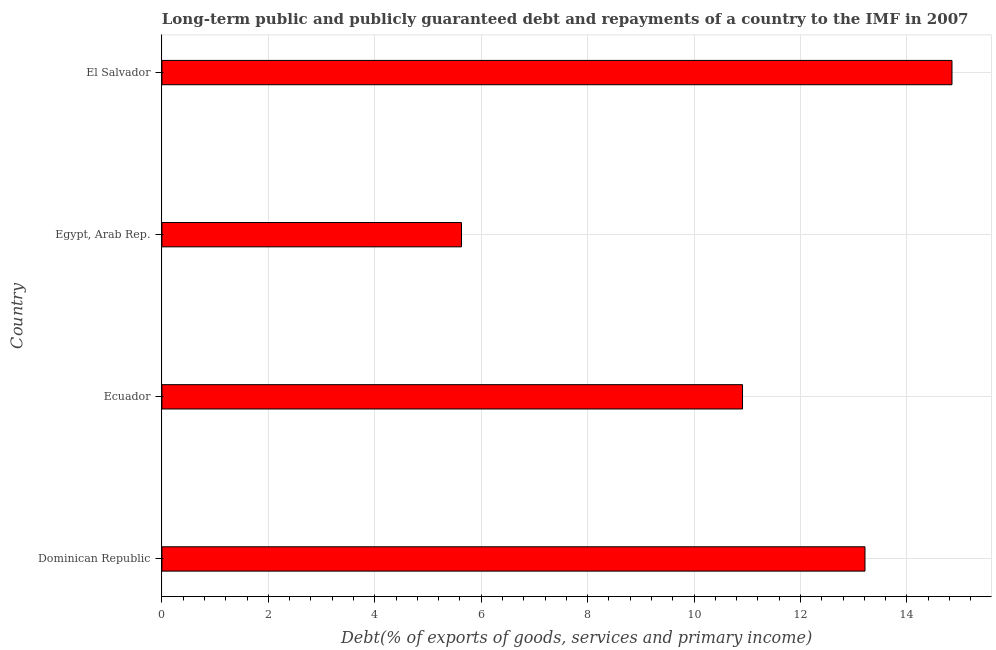Does the graph contain any zero values?
Offer a terse response. No. What is the title of the graph?
Provide a succinct answer. Long-term public and publicly guaranteed debt and repayments of a country to the IMF in 2007. What is the label or title of the X-axis?
Ensure brevity in your answer.  Debt(% of exports of goods, services and primary income). What is the debt service in El Salvador?
Keep it short and to the point. 14.85. Across all countries, what is the maximum debt service?
Ensure brevity in your answer.  14.85. Across all countries, what is the minimum debt service?
Your response must be concise. 5.63. In which country was the debt service maximum?
Offer a very short reply. El Salvador. In which country was the debt service minimum?
Offer a very short reply. Egypt, Arab Rep. What is the sum of the debt service?
Keep it short and to the point. 44.6. What is the difference between the debt service in Ecuador and Egypt, Arab Rep.?
Your response must be concise. 5.28. What is the average debt service per country?
Provide a short and direct response. 11.15. What is the median debt service?
Offer a terse response. 12.06. What is the ratio of the debt service in Dominican Republic to that in Ecuador?
Give a very brief answer. 1.21. Is the debt service in Ecuador less than that in El Salvador?
Keep it short and to the point. Yes. What is the difference between the highest and the second highest debt service?
Provide a succinct answer. 1.64. Is the sum of the debt service in Ecuador and Egypt, Arab Rep. greater than the maximum debt service across all countries?
Keep it short and to the point. Yes. What is the difference between the highest and the lowest debt service?
Your answer should be very brief. 9.22. How many bars are there?
Your response must be concise. 4. Are the values on the major ticks of X-axis written in scientific E-notation?
Your answer should be compact. No. What is the Debt(% of exports of goods, services and primary income) in Dominican Republic?
Ensure brevity in your answer.  13.21. What is the Debt(% of exports of goods, services and primary income) of Ecuador?
Offer a very short reply. 10.91. What is the Debt(% of exports of goods, services and primary income) of Egypt, Arab Rep.?
Your answer should be very brief. 5.63. What is the Debt(% of exports of goods, services and primary income) of El Salvador?
Your response must be concise. 14.85. What is the difference between the Debt(% of exports of goods, services and primary income) in Dominican Republic and Ecuador?
Keep it short and to the point. 2.3. What is the difference between the Debt(% of exports of goods, services and primary income) in Dominican Republic and Egypt, Arab Rep.?
Your response must be concise. 7.58. What is the difference between the Debt(% of exports of goods, services and primary income) in Dominican Republic and El Salvador?
Offer a terse response. -1.64. What is the difference between the Debt(% of exports of goods, services and primary income) in Ecuador and Egypt, Arab Rep.?
Your response must be concise. 5.28. What is the difference between the Debt(% of exports of goods, services and primary income) in Ecuador and El Salvador?
Your answer should be compact. -3.94. What is the difference between the Debt(% of exports of goods, services and primary income) in Egypt, Arab Rep. and El Salvador?
Provide a short and direct response. -9.22. What is the ratio of the Debt(% of exports of goods, services and primary income) in Dominican Republic to that in Ecuador?
Your response must be concise. 1.21. What is the ratio of the Debt(% of exports of goods, services and primary income) in Dominican Republic to that in Egypt, Arab Rep.?
Keep it short and to the point. 2.35. What is the ratio of the Debt(% of exports of goods, services and primary income) in Dominican Republic to that in El Salvador?
Your response must be concise. 0.89. What is the ratio of the Debt(% of exports of goods, services and primary income) in Ecuador to that in Egypt, Arab Rep.?
Keep it short and to the point. 1.94. What is the ratio of the Debt(% of exports of goods, services and primary income) in Ecuador to that in El Salvador?
Ensure brevity in your answer.  0.73. What is the ratio of the Debt(% of exports of goods, services and primary income) in Egypt, Arab Rep. to that in El Salvador?
Give a very brief answer. 0.38. 